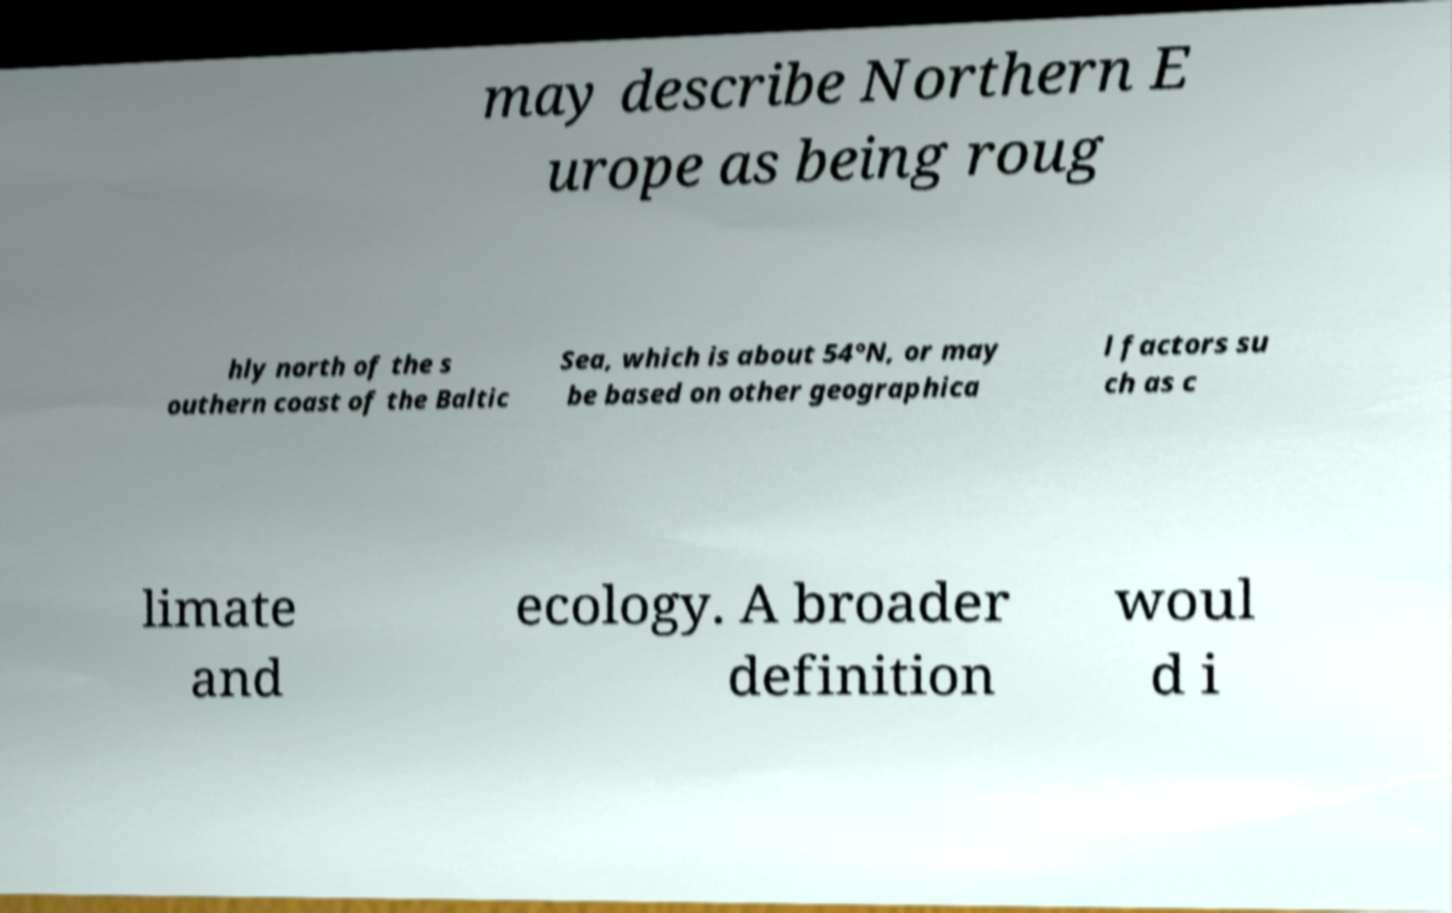There's text embedded in this image that I need extracted. Can you transcribe it verbatim? may describe Northern E urope as being roug hly north of the s outhern coast of the Baltic Sea, which is about 54°N, or may be based on other geographica l factors su ch as c limate and ecology. A broader definition woul d i 